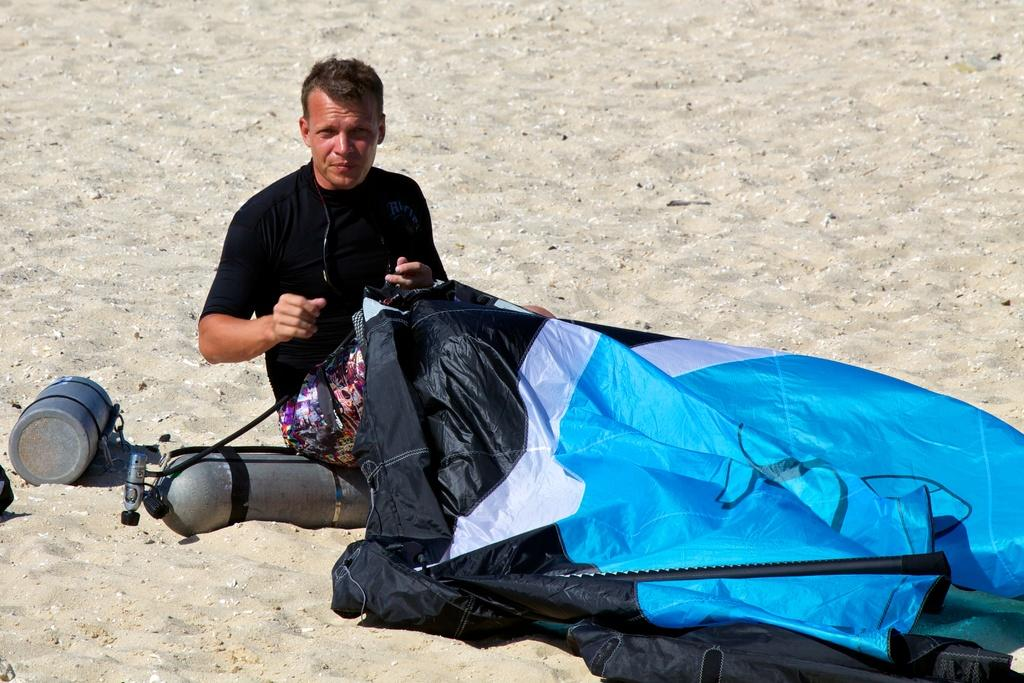Who is present in the image? There is a man in the image. What is the man wearing? The man is wearing a black dress. What objects can be seen near the man? The man is sitting near cylinders and a cover. What type of terrain is visible in the image? There is sand visible in the image. What type of knowledge does the man possess, as indicated by the image? The image does not provide any information about the man's knowledge. Can you hear the man laughing in the image? There is no sound in the image, so it is impossible to hear the man laughing. 